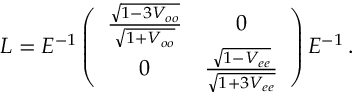<formula> <loc_0><loc_0><loc_500><loc_500>L = E ^ { - 1 } \left ( \begin{array} { c c } { { \frac { \sqrt { 1 - 3 V _ { o o } } } { \sqrt { 1 + V _ { o o } } } } } & { 0 } \\ { 0 } & { { \frac { \sqrt { 1 - V _ { e e } } } { \sqrt { 1 + 3 V _ { e e } } } } } \end{array} \right ) E ^ { - 1 } \, .</formula> 